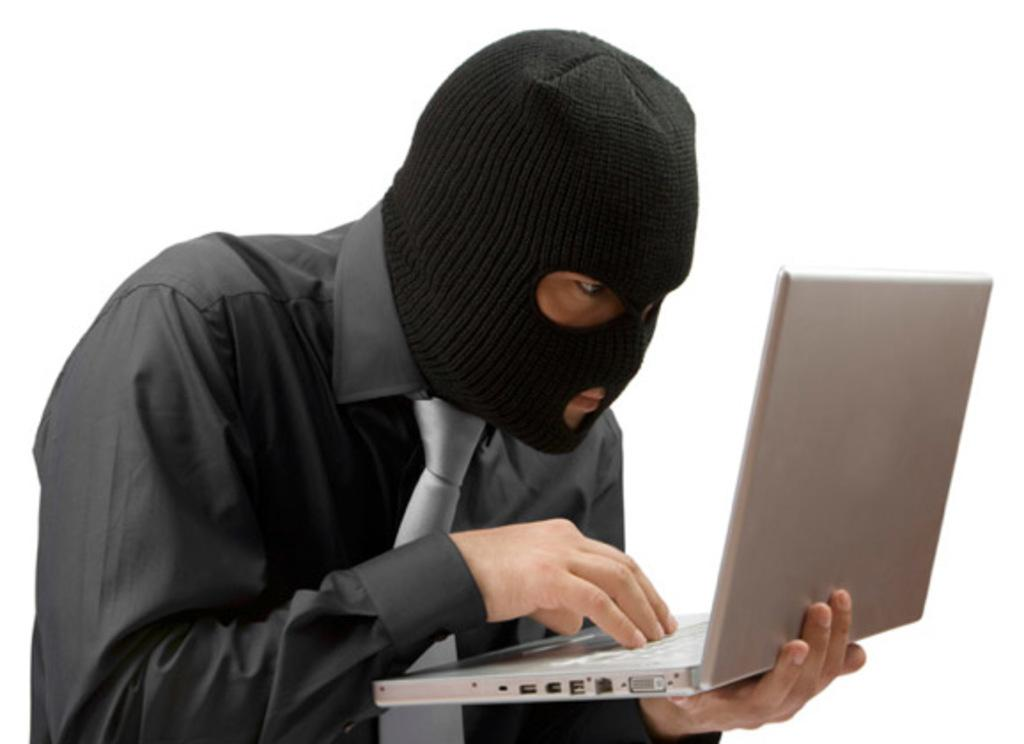What is the main subject of the picture? The main subject of the picture is a man. What is the man wearing on his upper body? The man is wearing a black shirt. What is the man wearing on his head? The man is wearing a black monkey cap on his head. What object is the man holding in the picture? The man is holding a laptop. What color is the background of the image? The background of the image is white. What flavor of ice cream is the man eating in the picture? There is no ice cream present in the image, and the man is not eating anything. 